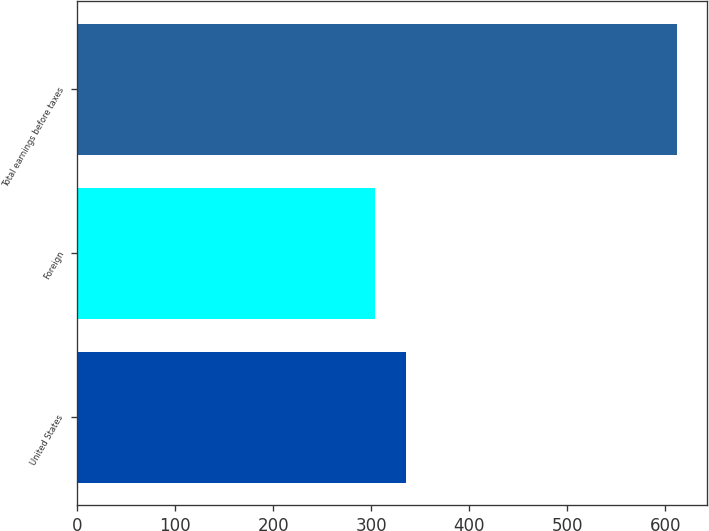Convert chart. <chart><loc_0><loc_0><loc_500><loc_500><bar_chart><fcel>United States<fcel>Foreign<fcel>Total earnings before taxes<nl><fcel>334.9<fcel>304.1<fcel>612.1<nl></chart> 